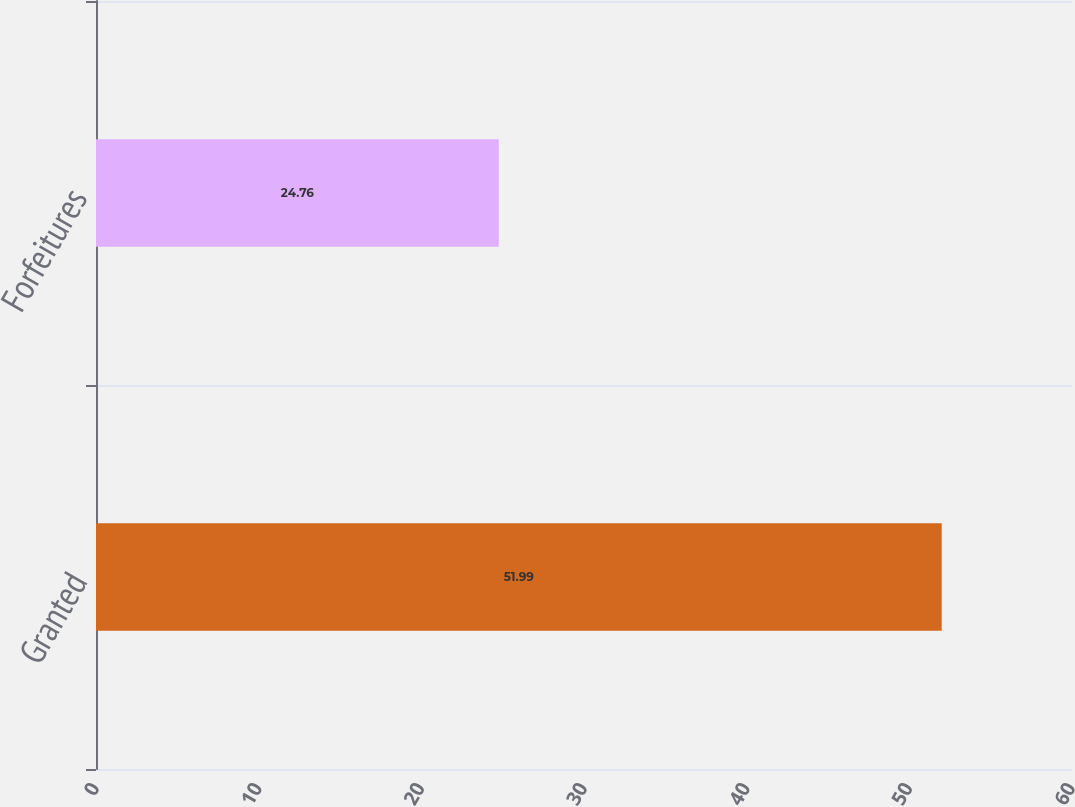Convert chart to OTSL. <chart><loc_0><loc_0><loc_500><loc_500><bar_chart><fcel>Granted<fcel>Forfeitures<nl><fcel>51.99<fcel>24.76<nl></chart> 